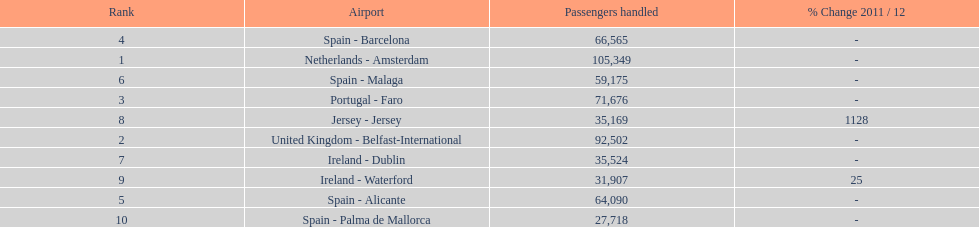Looking at the top 10 busiest routes to and from london southend airport what is the average number of passengers handled? 58,967.5. 